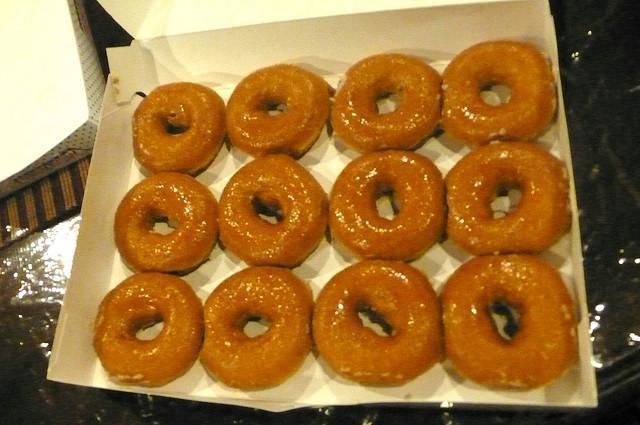How many donuts are there?
Give a very brief answer. 12. How many donuts are pictured?
Give a very brief answer. 12. How many donuts can be seen?
Give a very brief answer. 12. 